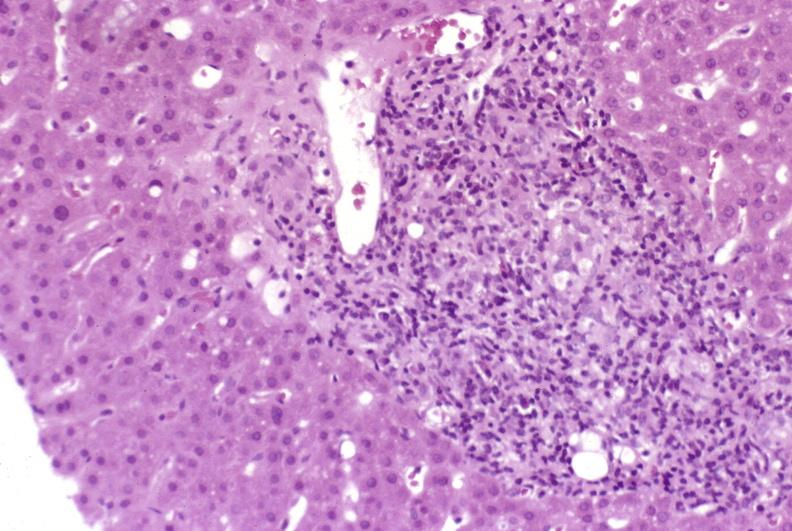s exostosis present?
Answer the question using a single word or phrase. No 